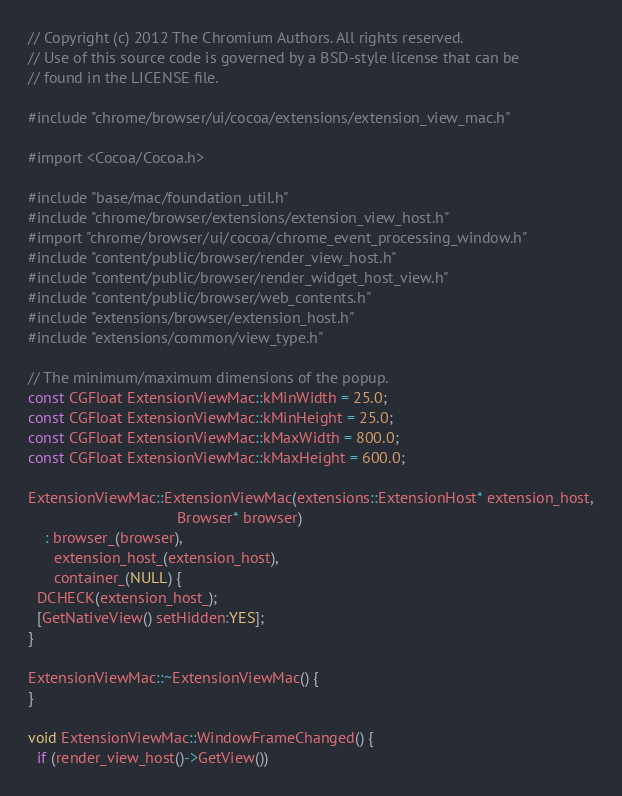<code> <loc_0><loc_0><loc_500><loc_500><_ObjectiveC_>// Copyright (c) 2012 The Chromium Authors. All rights reserved.
// Use of this source code is governed by a BSD-style license that can be
// found in the LICENSE file.

#include "chrome/browser/ui/cocoa/extensions/extension_view_mac.h"

#import <Cocoa/Cocoa.h>

#include "base/mac/foundation_util.h"
#include "chrome/browser/extensions/extension_view_host.h"
#import "chrome/browser/ui/cocoa/chrome_event_processing_window.h"
#include "content/public/browser/render_view_host.h"
#include "content/public/browser/render_widget_host_view.h"
#include "content/public/browser/web_contents.h"
#include "extensions/browser/extension_host.h"
#include "extensions/common/view_type.h"

// The minimum/maximum dimensions of the popup.
const CGFloat ExtensionViewMac::kMinWidth = 25.0;
const CGFloat ExtensionViewMac::kMinHeight = 25.0;
const CGFloat ExtensionViewMac::kMaxWidth = 800.0;
const CGFloat ExtensionViewMac::kMaxHeight = 600.0;

ExtensionViewMac::ExtensionViewMac(extensions::ExtensionHost* extension_host,
                                   Browser* browser)
    : browser_(browser),
      extension_host_(extension_host),
      container_(NULL) {
  DCHECK(extension_host_);
  [GetNativeView() setHidden:YES];
}

ExtensionViewMac::~ExtensionViewMac() {
}

void ExtensionViewMac::WindowFrameChanged() {
  if (render_view_host()->GetView())</code> 